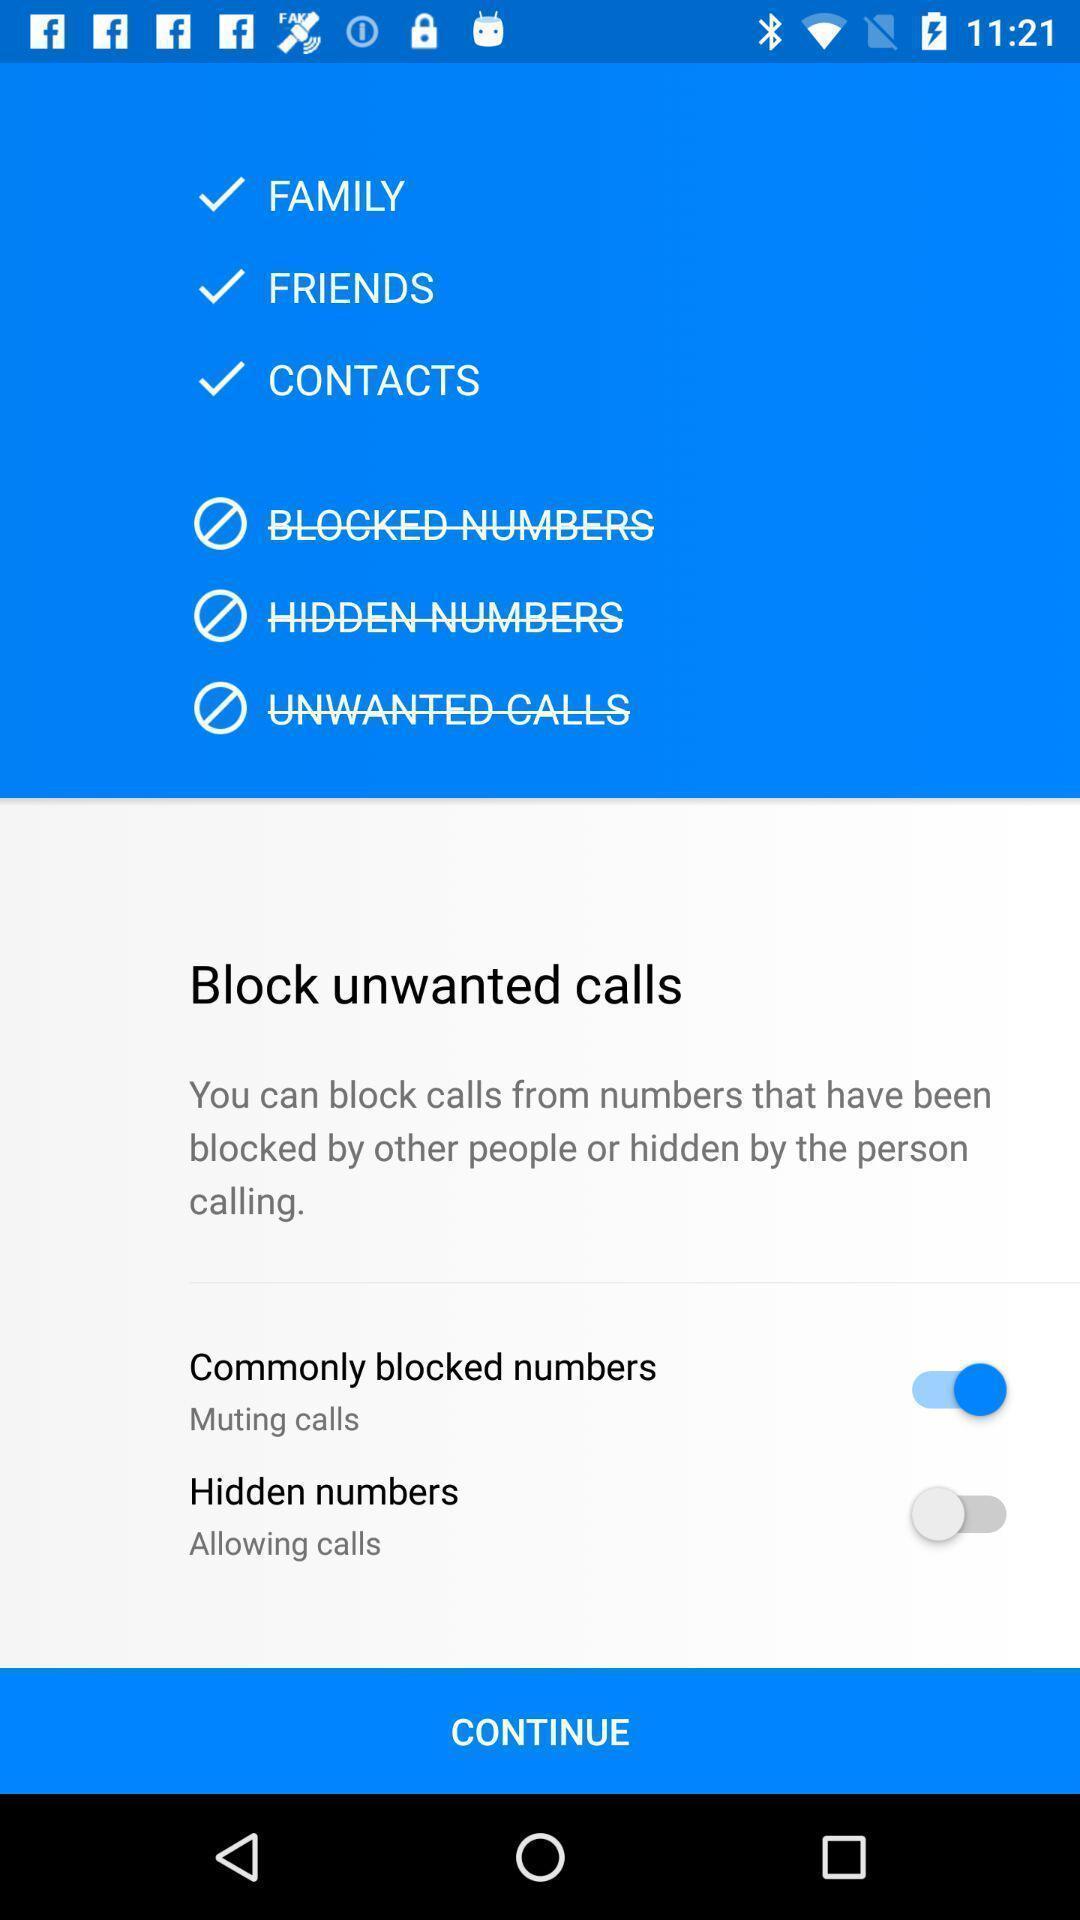Tell me about the visual elements in this screen capture. Page with list of options to block calls. 